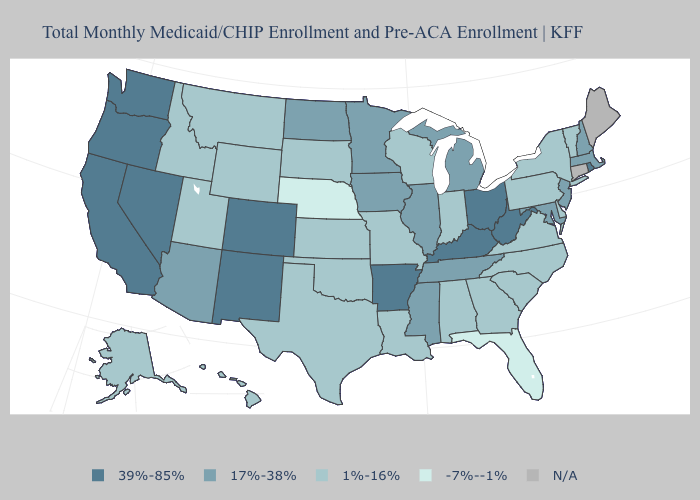Which states hav the highest value in the MidWest?
Quick response, please. Ohio. What is the lowest value in the USA?
Write a very short answer. -7%--1%. Name the states that have a value in the range N/A?
Write a very short answer. Connecticut, Maine. Among the states that border Georgia , which have the lowest value?
Write a very short answer. Florida. What is the value of California?
Write a very short answer. 39%-85%. What is the value of Virginia?
Keep it brief. 1%-16%. What is the value of Wisconsin?
Keep it brief. 1%-16%. What is the highest value in states that border Minnesota?
Quick response, please. 17%-38%. Does New Jersey have the lowest value in the USA?
Answer briefly. No. What is the value of Idaho?
Quick response, please. 1%-16%. Which states have the lowest value in the USA?
Write a very short answer. Florida, Nebraska. Name the states that have a value in the range 17%-38%?
Answer briefly. Arizona, Illinois, Iowa, Maryland, Massachusetts, Michigan, Minnesota, Mississippi, New Hampshire, New Jersey, North Dakota, Tennessee. What is the value of Michigan?
Keep it brief. 17%-38%. What is the value of Ohio?
Short answer required. 39%-85%. How many symbols are there in the legend?
Keep it brief. 5. 